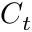<formula> <loc_0><loc_0><loc_500><loc_500>C _ { t }</formula> 